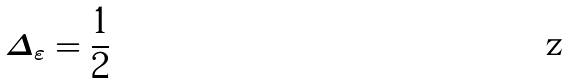<formula> <loc_0><loc_0><loc_500><loc_500>\Delta _ { \varepsilon } = \frac { 1 } { 2 }</formula> 